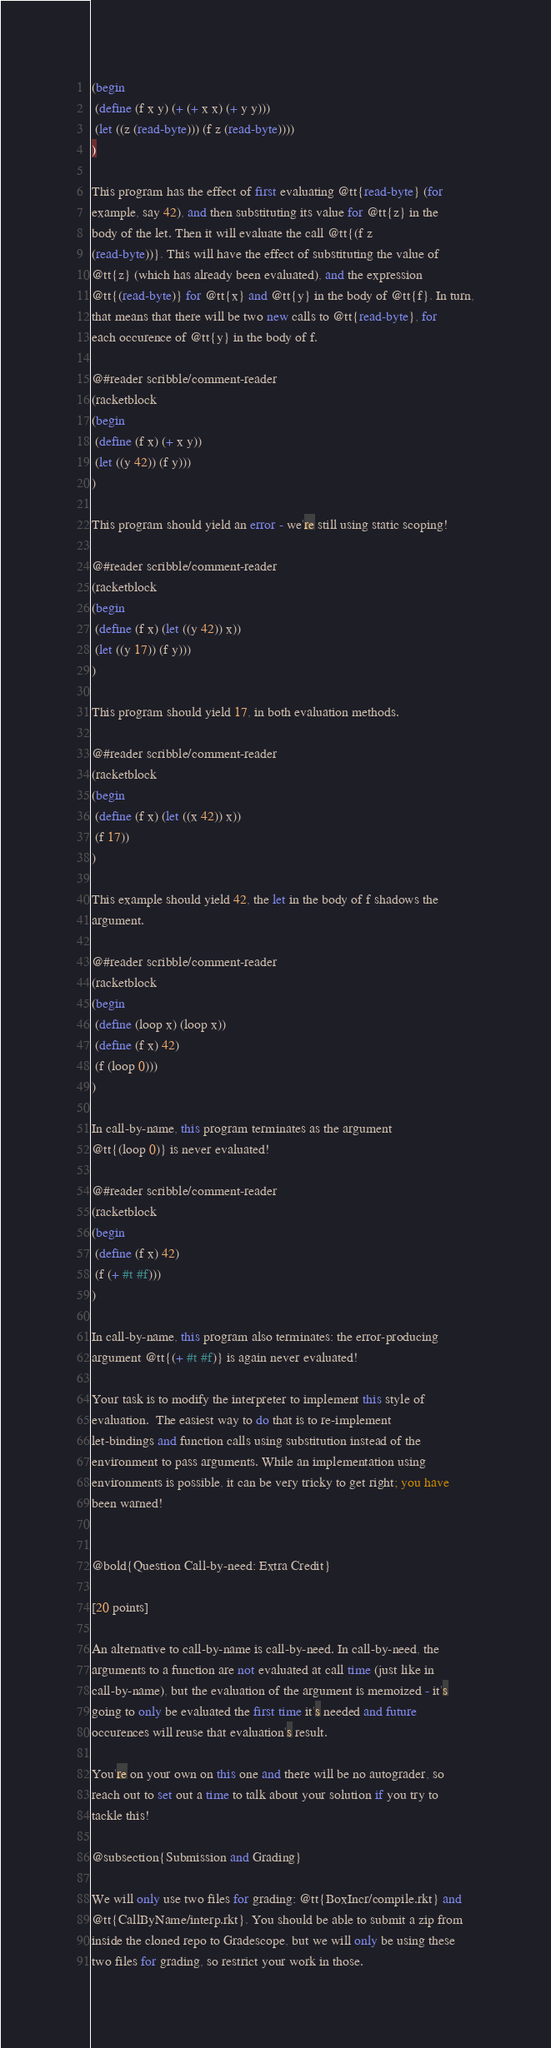<code> <loc_0><loc_0><loc_500><loc_500><_Racket_>(begin
 (define (f x y) (+ (+ x x) (+ y y)))
 (let ((z (read-byte))) (f z (read-byte))))
)

This program has the effect of first evaluating @tt{read-byte} (for
example, say 42), and then substituting its value for @tt{z} in the
body of the let. Then it will evaluate the call @tt{(f z
(read-byte))}. This will have the effect of substituting the value of
@tt{z} (which has already been evaluated), and the expression
@tt{(read-byte)} for @tt{x} and @tt{y} in the body of @tt{f}. In turn,
that means that there will be two new calls to @tt{read-byte}, for
each occurence of @tt{y} in the body of f.

@#reader scribble/comment-reader
(racketblock
(begin
 (define (f x) (+ x y))
 (let ((y 42)) (f y)))
)

This program should yield an error - we're still using static scoping!

@#reader scribble/comment-reader
(racketblock
(begin
 (define (f x) (let ((y 42)) x))
 (let ((y 17)) (f y)))
)

This program should yield 17, in both evaluation methods.

@#reader scribble/comment-reader
(racketblock
(begin
 (define (f x) (let ((x 42)) x))
 (f 17))
)

This example should yield 42, the let in the body of f shadows the
argument. 

@#reader scribble/comment-reader
(racketblock
(begin
 (define (loop x) (loop x))
 (define (f x) 42)
 (f (loop 0)))
)

In call-by-name, this program terminates as the argument
@tt{(loop 0)} is never evaluated!

@#reader scribble/comment-reader
(racketblock
(begin
 (define (f x) 42)
 (f (+ #t #f)))
)

In call-by-name, this program also terminates: the error-producing
argument @tt{(+ #t #f)} is again never evaluated!

Your task is to modify the interpreter to implement this style of
evaluation.  The easiest way to do that is to re-implement
let-bindings and function calls using substitution instead of the
environment to pass arguments. While an implementation using
environments is possible, it can be very tricky to get right; you have
been warned!


@bold{Question Call-by-need: Extra Credit}

[20 points]

An alternative to call-by-name is call-by-need. In call-by-need, the
arguments to a function are not evaluated at call time (just like in
call-by-name), but the evaluation of the argument is memoized - it's
going to only be evaluated the first time it's needed and future
occurences will reuse that evaluation's result.

You're on your own on this one and there will be no autograder, so
reach out to set out a time to talk about your solution if you try to
tackle this!

@subsection{Submission and Grading}

We will only use two files for grading: @tt{BoxIncr/compile.rkt} and
@tt{CallByName/interp.rkt}. You should be able to submit a zip from
inside the cloned repo to Gradescope, but we will only be using these
two files for grading, so restrict your work in those.</code> 